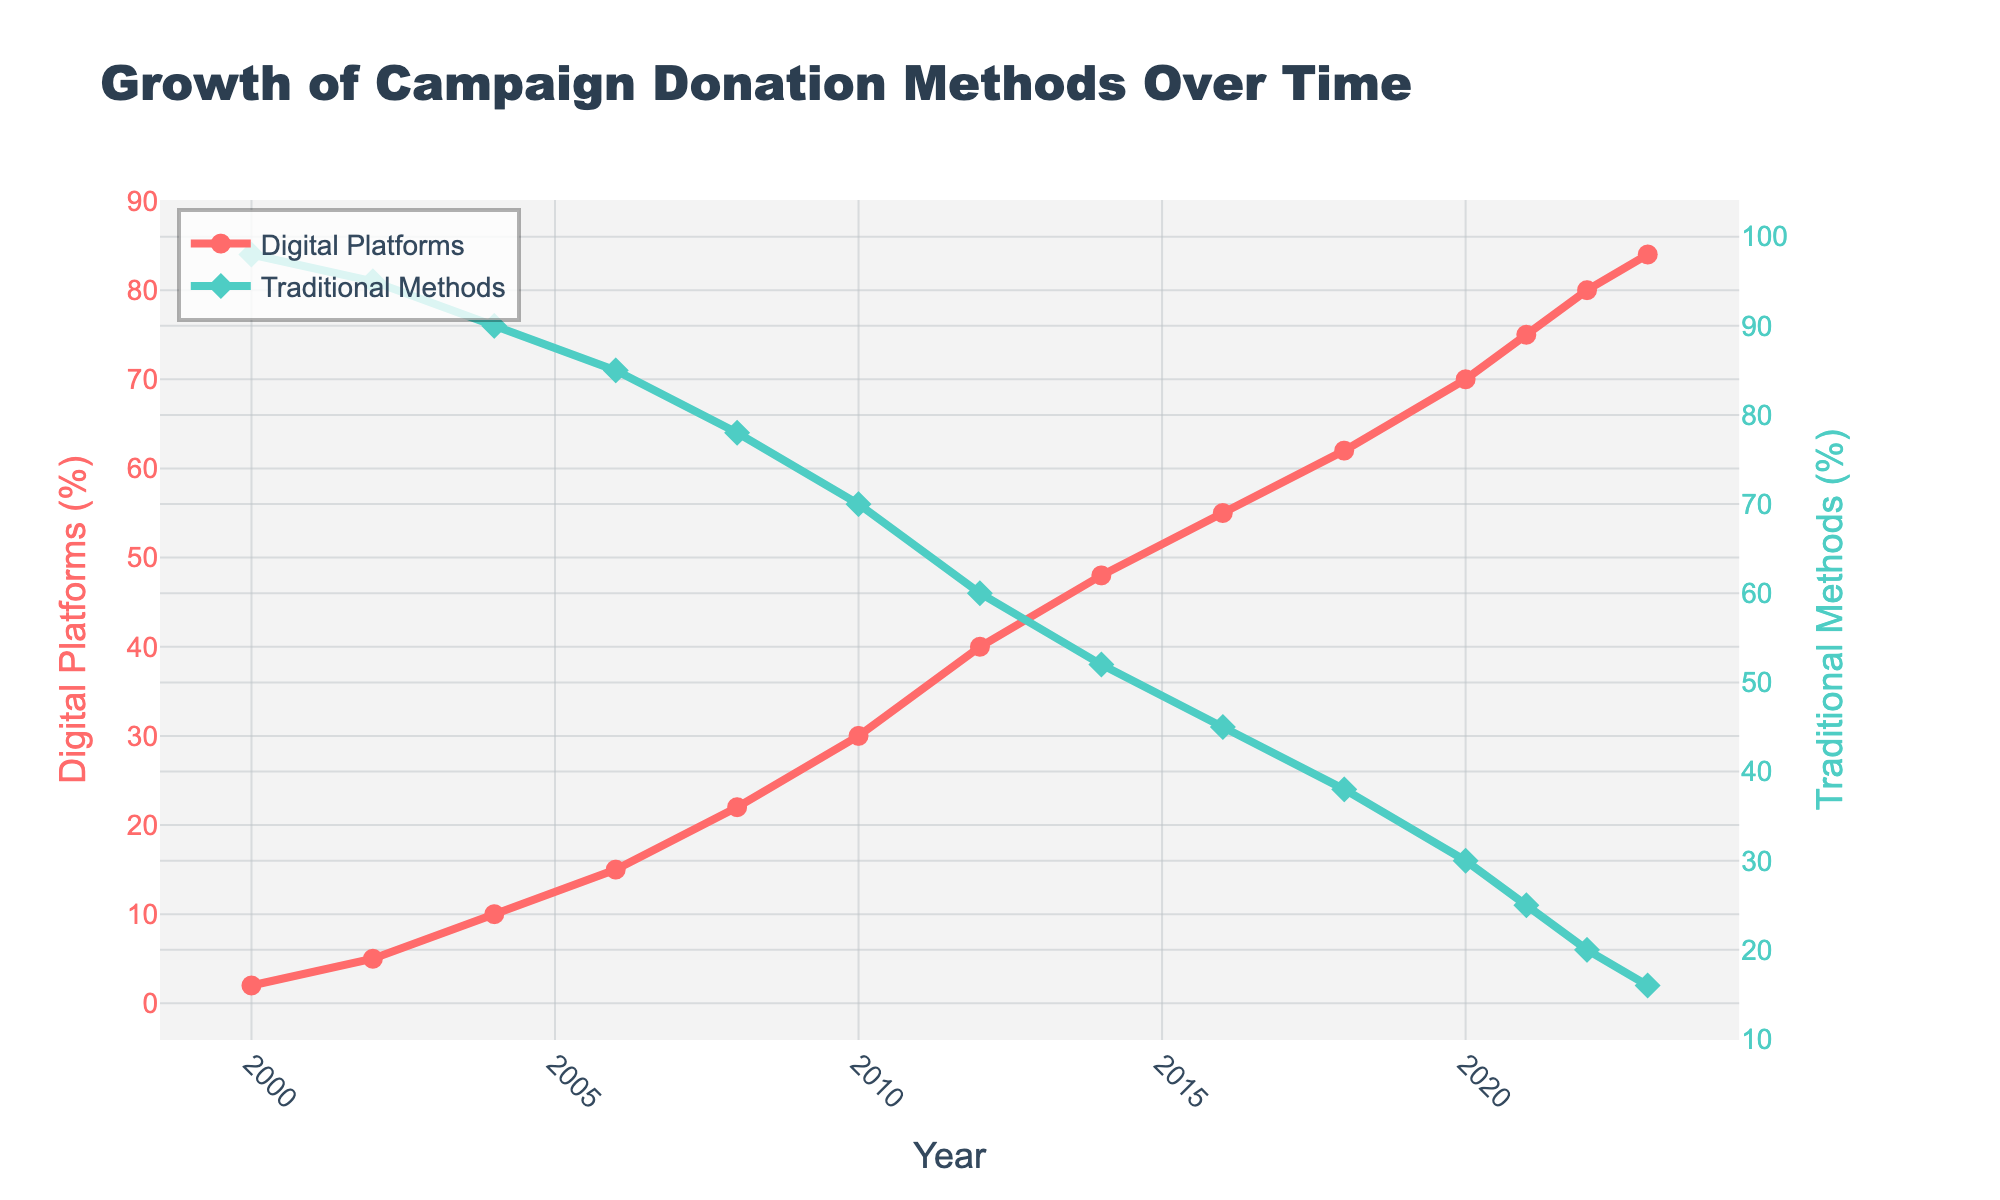What is the overall trend for donation amounts through digital platforms over time? The donation amounts through digital platforms have been consistently increasing from 2000 to 2023, starting at 2% in 2000 and rising to 84% in 2023.
Answer: Increasing How did the percentage of donations via traditional methods change between 2000 and 2023? The percentage of donations via traditional methods decreased from 98% in 2000 to 16% in 2023, showing a significant decline over the years.
Answer: Decreased In which year did donations through digital platforms surpass traditional methods? Donations through digital platforms surpassed traditional methods in 2016, where digital platforms were at 55% and traditional methods at 45%.
Answer: 2016 By how many percentage points did digital platform donations increase from 2010 to 2020? In 2010, digital platform donations were at 30%, and in 2020, they were at 70%. The increase is 70% - 30% = 40 percentage points.
Answer: 40 percentage points What is the difference in the percentage of donations through traditional methods between 2002 and 2012? In 2002, traditional methods accounted for 95%, and in 2012, they accounted for 60%. The difference is 95% - 60% = 35 percentage points.
Answer: 35 percentage points Which share (digital or traditional) witnessed a higher growth rate from 2000 to 2023, and by how much? Digital platforms witnessed a higher growth rate. In 2000, digital platforms were at 2% and increased to 84% in 2023, showing an 82 percentage-point increase. Traditional methods decreased from 98% to 16%, showing an 82 percentage-point decrease.
Answer: Digital platforms by 82 percentage points What is the approximate average percentage of donations through digital platforms from 2000 to 2023? The percentages over the years are: [2, 5, 10, 15, 22, 30, 40, 48, 55, 62, 70, 75, 80, 84]. Adding these gives 598. Dividing by 14 (number of years), the average is approximately 42.7%.
Answer: 42.7% During which year did the largest single-year percentage increase in digital platform donations occur, and what was the increase? The largest single-year percentage increase occurred between 2010 (30%) and 2012 (40%). The increase is 40% - 30% = 10 percentage points.
Answer: 2012, 10 percentage points 